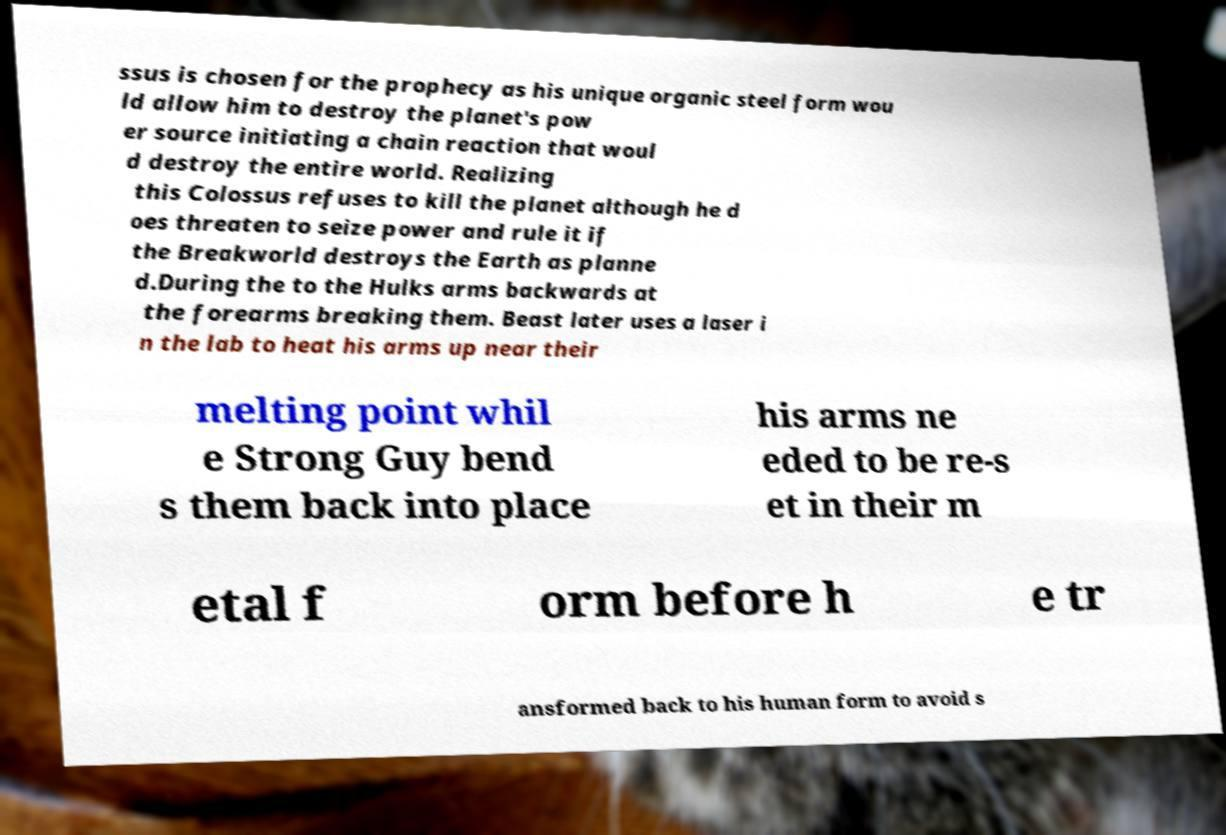I need the written content from this picture converted into text. Can you do that? ssus is chosen for the prophecy as his unique organic steel form wou ld allow him to destroy the planet's pow er source initiating a chain reaction that woul d destroy the entire world. Realizing this Colossus refuses to kill the planet although he d oes threaten to seize power and rule it if the Breakworld destroys the Earth as planne d.During the to the Hulks arms backwards at the forearms breaking them. Beast later uses a laser i n the lab to heat his arms up near their melting point whil e Strong Guy bend s them back into place his arms ne eded to be re-s et in their m etal f orm before h e tr ansformed back to his human form to avoid s 